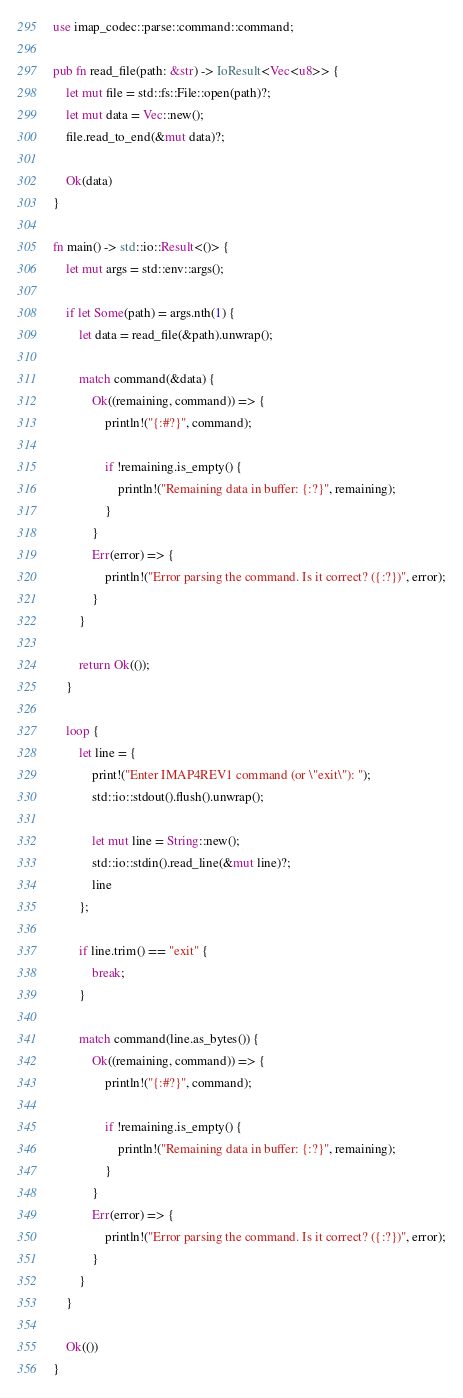Convert code to text. <code><loc_0><loc_0><loc_500><loc_500><_Rust_>
use imap_codec::parse::command::command;

pub fn read_file(path: &str) -> IoResult<Vec<u8>> {
    let mut file = std::fs::File::open(path)?;
    let mut data = Vec::new();
    file.read_to_end(&mut data)?;

    Ok(data)
}

fn main() -> std::io::Result<()> {
    let mut args = std::env::args();

    if let Some(path) = args.nth(1) {
        let data = read_file(&path).unwrap();

        match command(&data) {
            Ok((remaining, command)) => {
                println!("{:#?}", command);

                if !remaining.is_empty() {
                    println!("Remaining data in buffer: {:?}", remaining);
                }
            }
            Err(error) => {
                println!("Error parsing the command. Is it correct? ({:?})", error);
            }
        }

        return Ok(());
    }

    loop {
        let line = {
            print!("Enter IMAP4REV1 command (or \"exit\"): ");
            std::io::stdout().flush().unwrap();

            let mut line = String::new();
            std::io::stdin().read_line(&mut line)?;
            line
        };

        if line.trim() == "exit" {
            break;
        }

        match command(line.as_bytes()) {
            Ok((remaining, command)) => {
                println!("{:#?}", command);

                if !remaining.is_empty() {
                    println!("Remaining data in buffer: {:?}", remaining);
                }
            }
            Err(error) => {
                println!("Error parsing the command. Is it correct? ({:?})", error);
            }
        }
    }

    Ok(())
}
</code> 